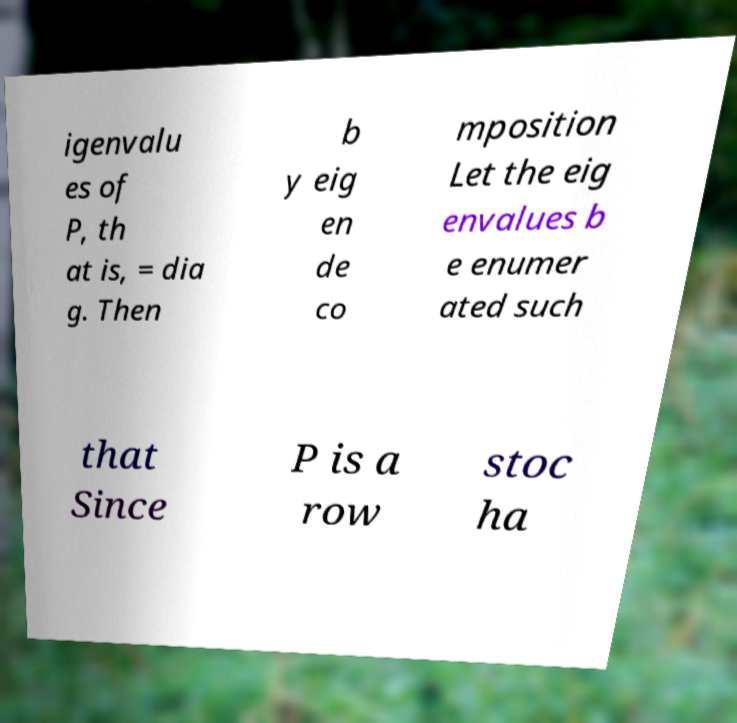For documentation purposes, I need the text within this image transcribed. Could you provide that? igenvalu es of P, th at is, = dia g. Then b y eig en de co mposition Let the eig envalues b e enumer ated such that Since P is a row stoc ha 